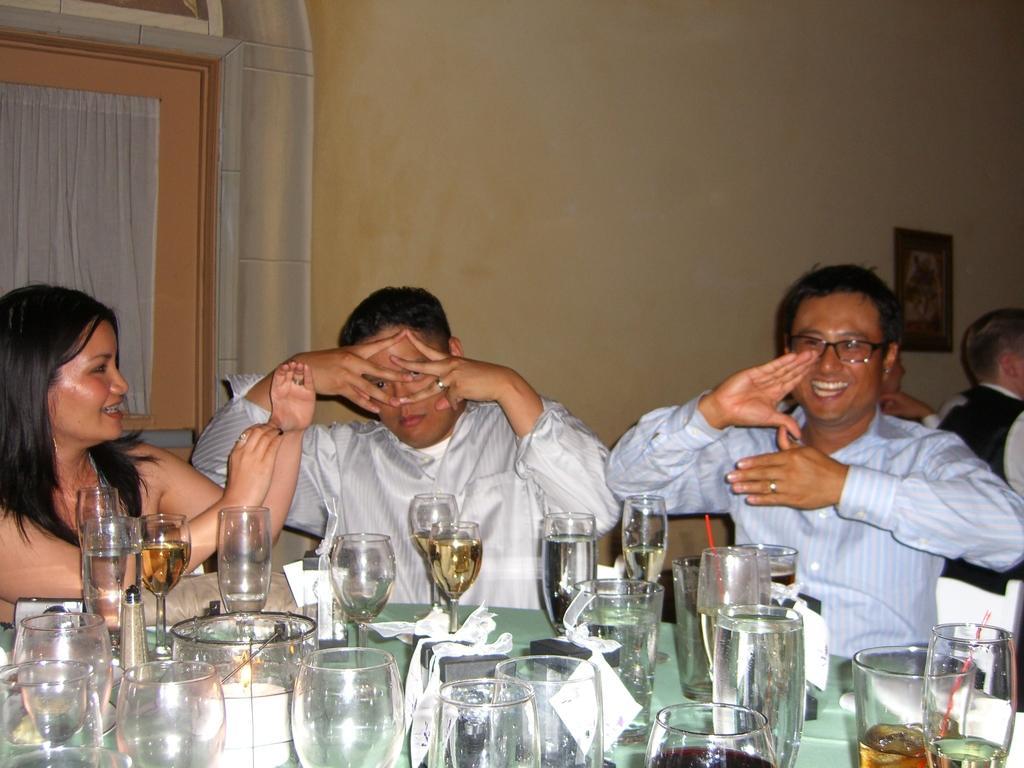Please provide a concise description of this image. In this image we can see a group of people sitting. In the foreground we can see group of glasses, boxes with ribbons, candle and a device are placed on the table. On the left side of the image we can see the curtains. On the right side of the image we can see a photo frame on the wall. 